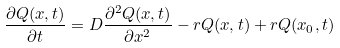Convert formula to latex. <formula><loc_0><loc_0><loc_500><loc_500>\frac { \partial Q ( x , t ) } { \partial t } = D \frac { \partial ^ { 2 } Q ( x , t ) } { \partial x ^ { 2 } } - r Q ( x , t ) + r Q ( x _ { 0 } , t )</formula> 